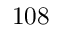Convert formula to latex. <formula><loc_0><loc_0><loc_500><loc_500>1 0 8</formula> 